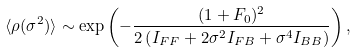<formula> <loc_0><loc_0><loc_500><loc_500>\langle \rho ( \sigma ^ { 2 } ) \rangle \sim \exp \left ( - \frac { ( 1 + F _ { 0 } ) ^ { 2 } } { 2 \left ( I _ { F F } + 2 \sigma ^ { 2 } I _ { F B } + \sigma ^ { 4 } I _ { B B } \right ) } \right ) ,</formula> 